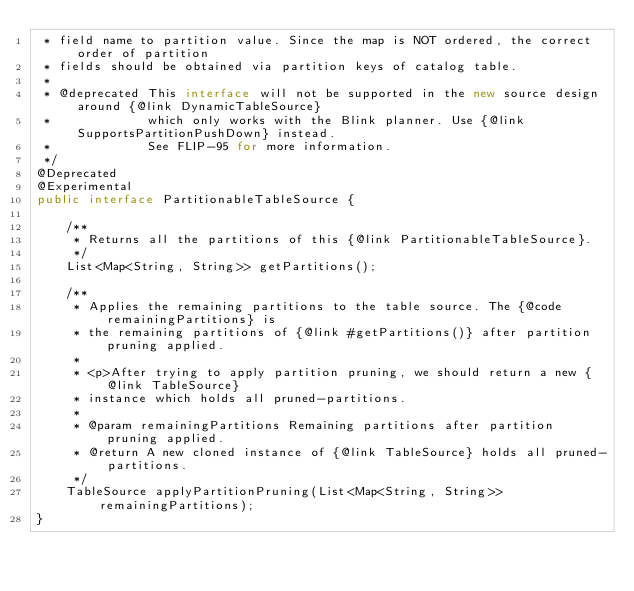Convert code to text. <code><loc_0><loc_0><loc_500><loc_500><_Java_> * field name to partition value. Since the map is NOT ordered, the correct order of partition
 * fields should be obtained via partition keys of catalog table.
 *
 * @deprecated This interface will not be supported in the new source design around {@link DynamicTableSource}
 *             which only works with the Blink planner. Use {@link SupportsPartitionPushDown} instead.
 *             See FLIP-95 for more information.
 */
@Deprecated
@Experimental
public interface PartitionableTableSource {

	/**
	 * Returns all the partitions of this {@link PartitionableTableSource}.
	 */
	List<Map<String, String>> getPartitions();

	/**
	 * Applies the remaining partitions to the table source. The {@code remainingPartitions} is
	 * the remaining partitions of {@link #getPartitions()} after partition pruning applied.
	 *
	 * <p>After trying to apply partition pruning, we should return a new {@link TableSource}
	 * instance which holds all pruned-partitions.
	 *
	 * @param remainingPartitions Remaining partitions after partition pruning applied.
	 * @return A new cloned instance of {@link TableSource} holds all pruned-partitions.
	 */
	TableSource applyPartitionPruning(List<Map<String, String>> remainingPartitions);
}
</code> 